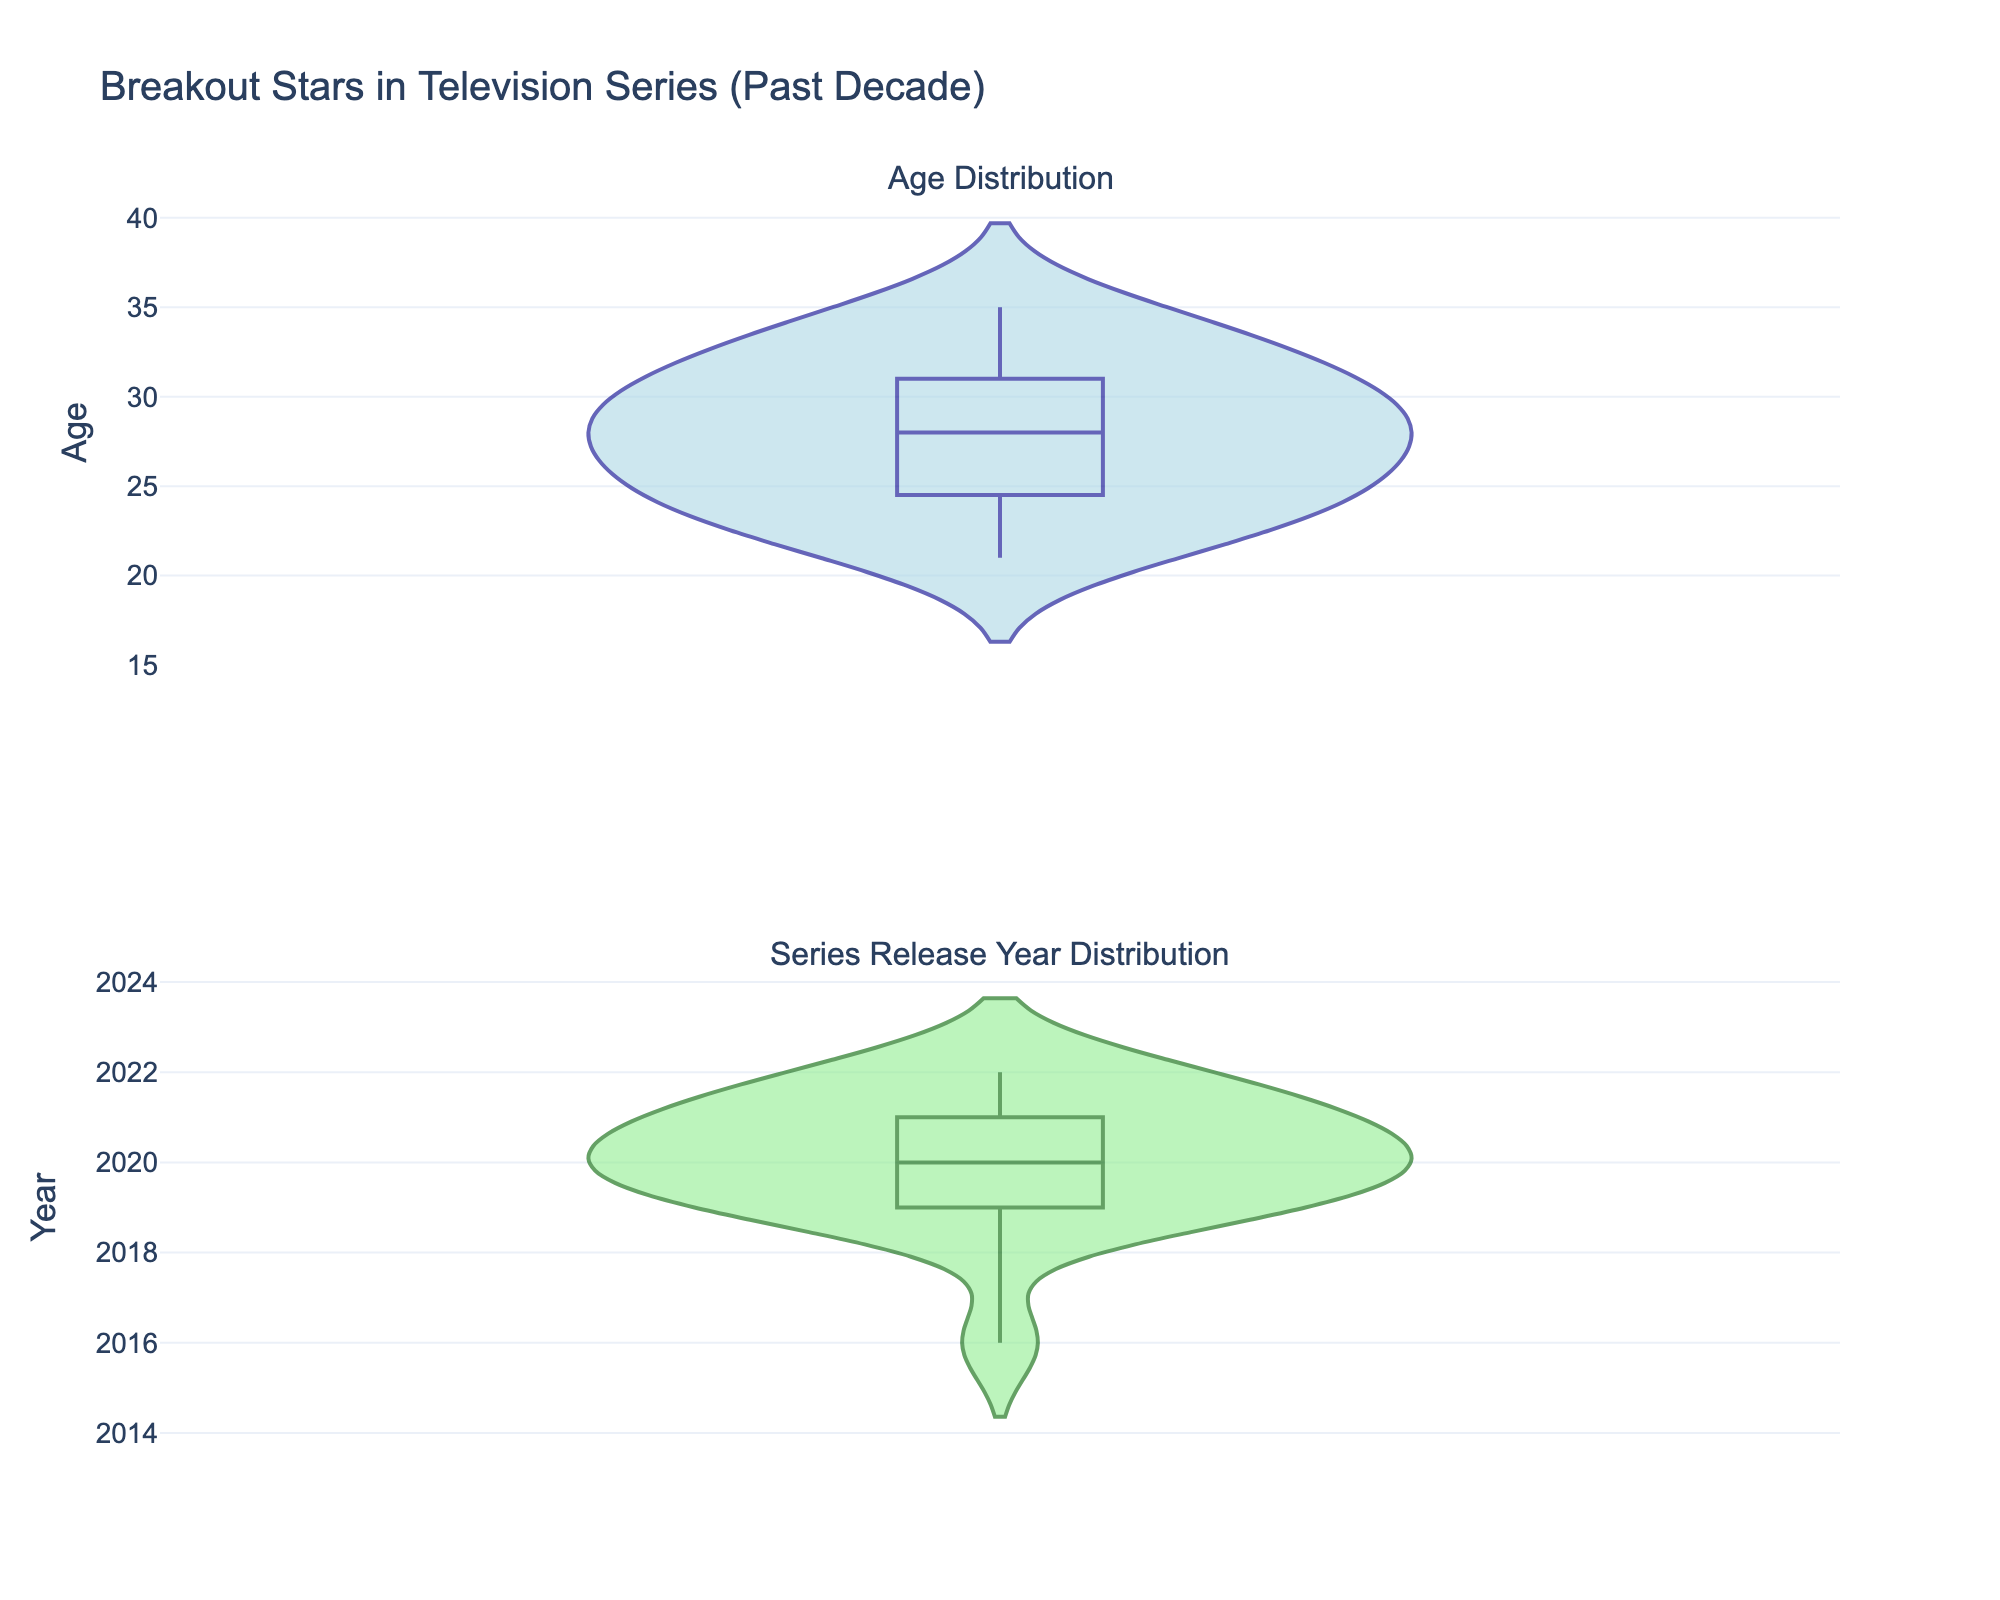What is the title of the figure? The title of a figure is typically found at the top and summarizes the main topic or data represented. In this case, reading the title from the top of the figure will give you this information.
Answer: Breakout Stars in Television Series (Past Decade) What are the y-axis labels for both subplots? Each subplot has its own y-axis label, which describes what is being measured along that axis. The first subplot has "Age" and the second subplot has "Year".
Answer: Age and Year What are the colors used for the violin plots in the Age and Year distributions? The colors of the violin plots can be identified by looking at the figures. The Age plot uses a combination of dark blue (line color) and light blue (fill color), and the Year plot uses dark green (line color) and light green (fill color).
Answer: Dark blue and light blue for Age, dark green and light green for Year Which subplot has a wider range of values, Age or Year? To determine which subplot has a wider range, you visually inspect the spread of the values in each violin plot. The "Year" subplot has values ranging from about 2016 to 2022, whereas the "Age" subplot ranges from around 21 to 35.
Answer: Age What is the median age of breakout stars? The median age can be approximated by looking at the middle point of the violin plot for Age, where the box within the violin indicates the interquartile range. The median is the line within that box. The median appears to be around 28.
Answer: Around 28 What year saw the most TV series with breakout stars based on the distribution? In a violin plot, the density (thickness) of the plot indicates the concentration of data points. The year with the most breakout stars will have the thickest part of the violin. The year 2020 appears to be the thickest, indicating the highest number of series.
Answer: 2020 By how many years do the youngest breakout stars differ from the oldest based on the distribution? To find the difference between the youngest and oldest breakout stars, observe the minimum and maximum values in the Age plot. The youngest is around 21, and the oldest is around 35, resulting in a difference of 14 years.
Answer: 14 years Compare the spread of ages to the spread of years. Which one is broader? Comparing the width of the spread visually suggests that the Age distribution (21-35) covers 14 years, whereas the Year distribution (2016-2022) covers 6 years.
Answer: Age distribution Is there any data point that appears to be an outlier in either subplot? Outliers are typically visible as points outside the main bulk of the data in a violin plot. Neither subplot for Age nor Year appears to have significant outliers, as they follow relatively smooth distributions.
Answer: No 